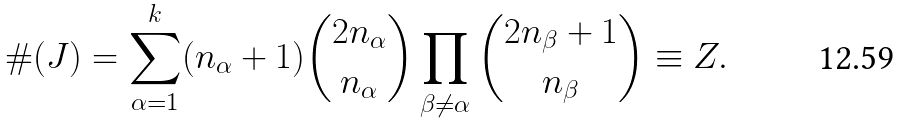Convert formula to latex. <formula><loc_0><loc_0><loc_500><loc_500>\# ( J ) = \sum _ { \alpha = 1 } ^ { k } ( n _ { \alpha } + 1 ) \binom { 2 n _ { \alpha } } { n _ { \alpha } } \prod _ { \beta \neq \alpha } \binom { 2 n _ { \beta } + 1 } { n _ { \beta } } \equiv Z .</formula> 